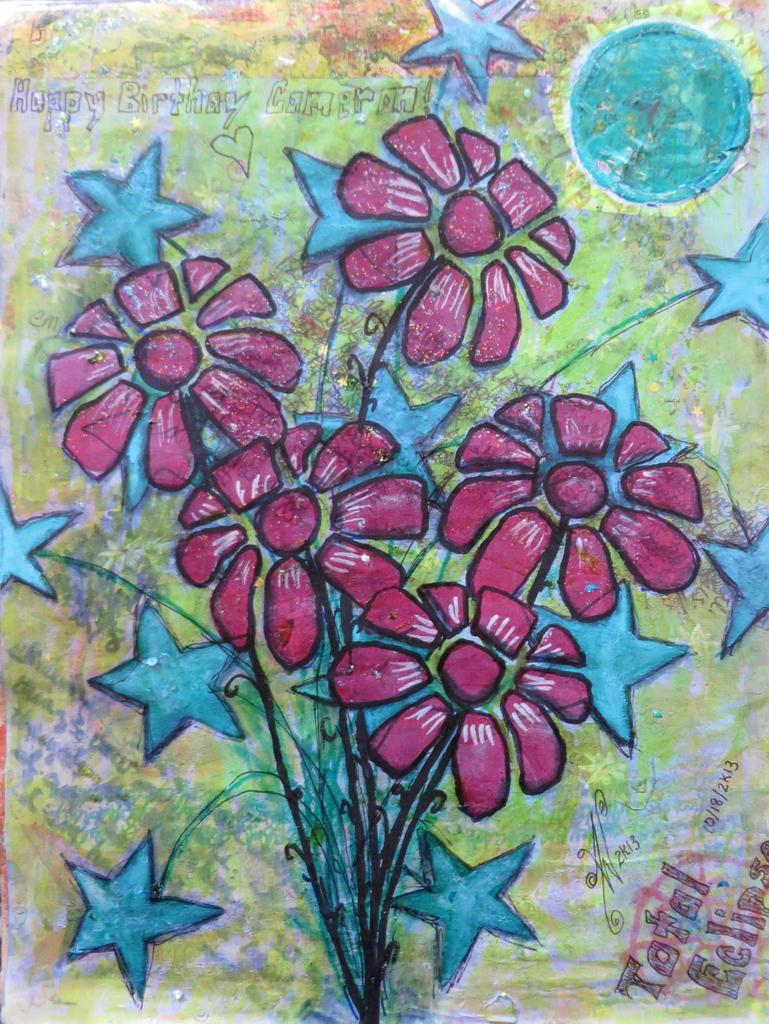What is the main subject of the image? There is a painting in the image. What is the painting depicting? The painting depicts a bunch of flowers. Where is the coat hanging in the image? There is no coat present in the image; it only features a painting of a bunch of flowers. 